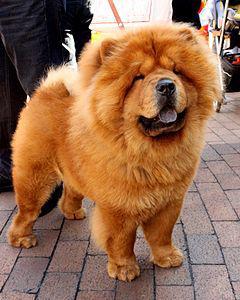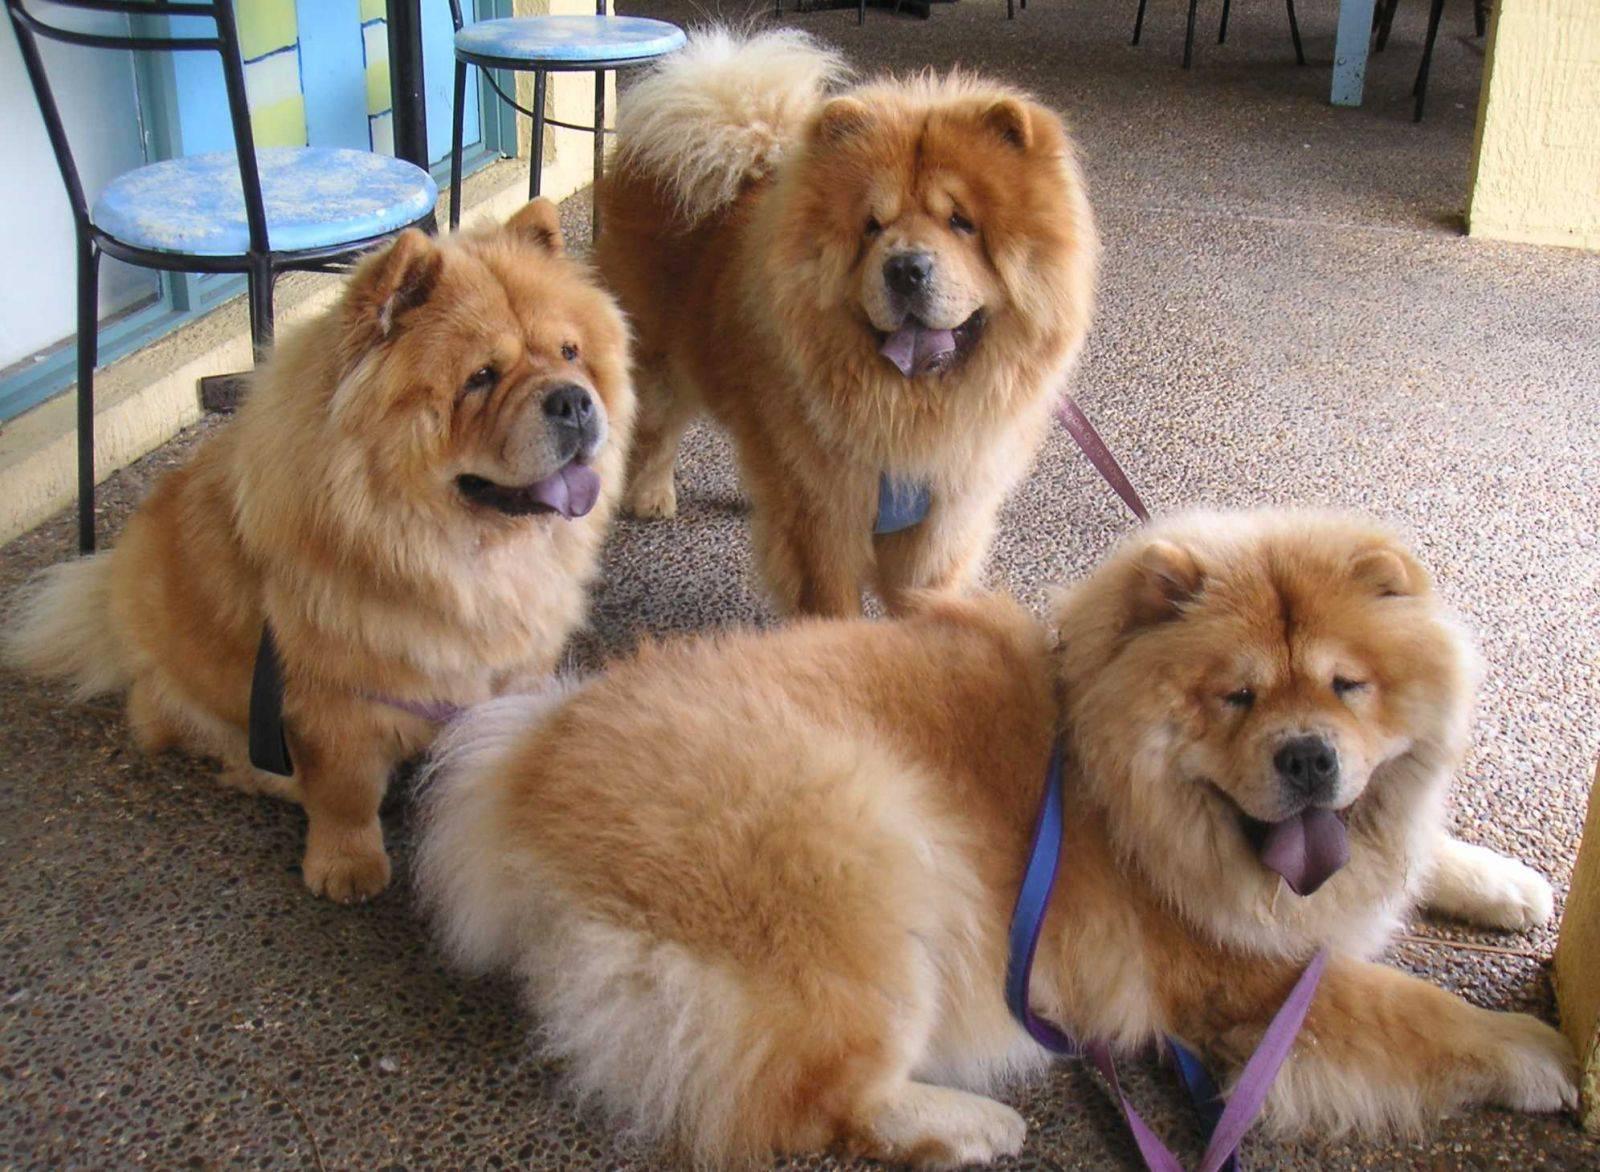The first image is the image on the left, the second image is the image on the right. Evaluate the accuracy of this statement regarding the images: "There are no less than three dogs". Is it true? Answer yes or no. Yes. The first image is the image on the left, the second image is the image on the right. Assess this claim about the two images: "The dog in the left image is orange and faces rightward.". Correct or not? Answer yes or no. Yes. 